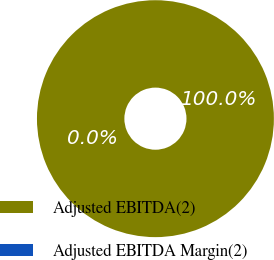Convert chart to OTSL. <chart><loc_0><loc_0><loc_500><loc_500><pie_chart><fcel>Adjusted EBITDA(2)<fcel>Adjusted EBITDA Margin(2)<nl><fcel>100.0%<fcel>0.0%<nl></chart> 